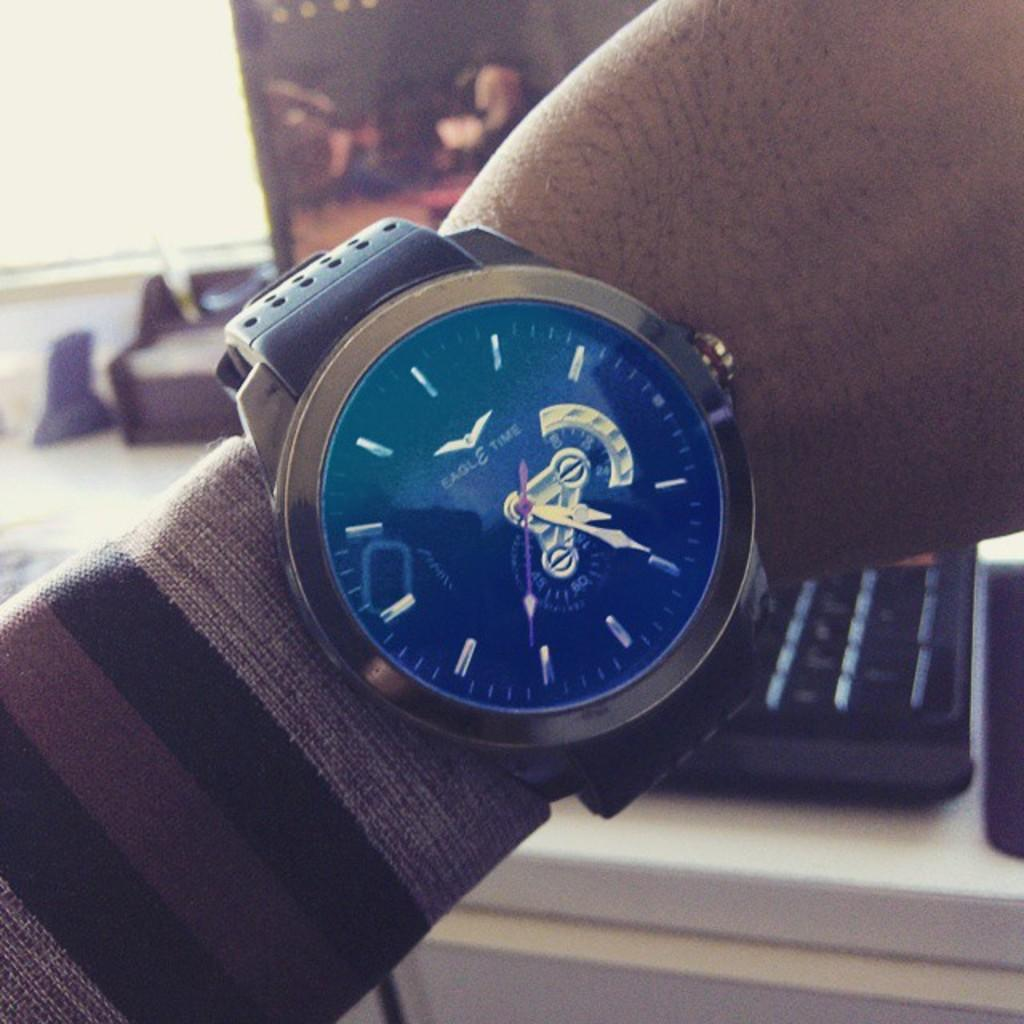<image>
Summarize the visual content of the image. Person holding up their watch which says Eagle Time on it. 